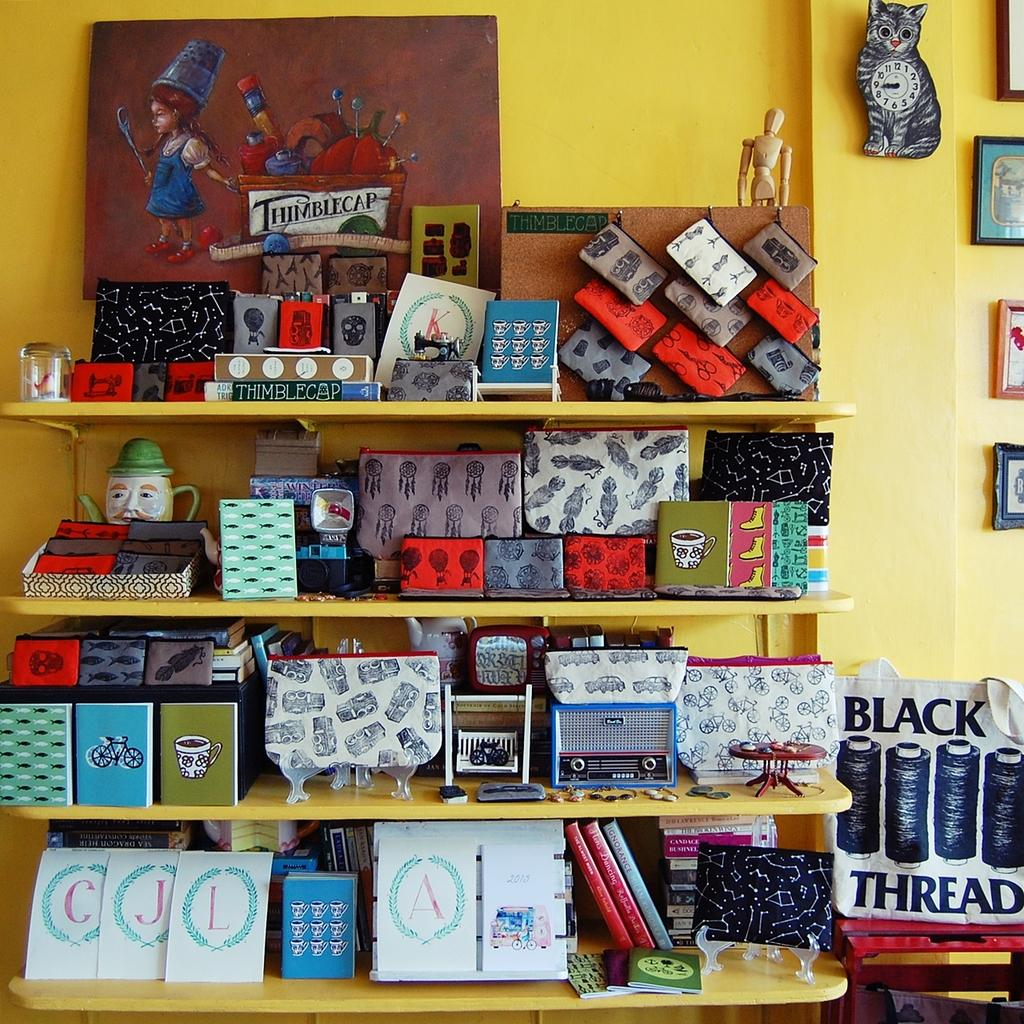What type of storage units are visible in the image? There are shelves in the image. What can be found on the shelves? There are boxes and other items on the shelves. What is hanging on the wall in the image? There are photo frames and a clock on the wall. What is the title of the book on the top shelf? There is no book visible on the shelves in the image. How much income does the person in the image earn? The image does not provide any information about the person's income. 